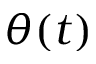<formula> <loc_0><loc_0><loc_500><loc_500>\theta ( t )</formula> 